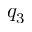<formula> <loc_0><loc_0><loc_500><loc_500>q _ { 3 }</formula> 